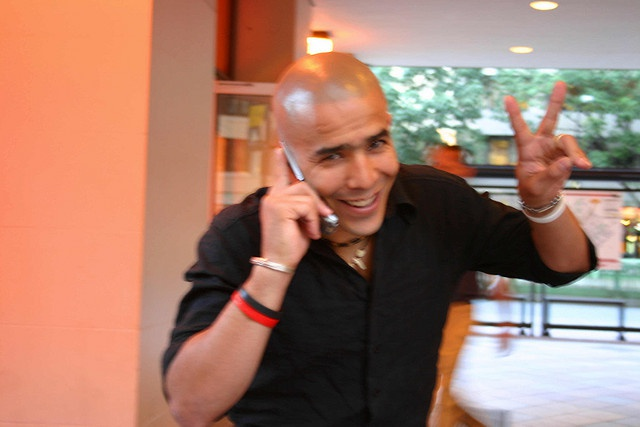Describe the objects in this image and their specific colors. I can see people in salmon, black, and brown tones and cell phone in salmon, darkgray, maroon, lavender, and black tones in this image. 